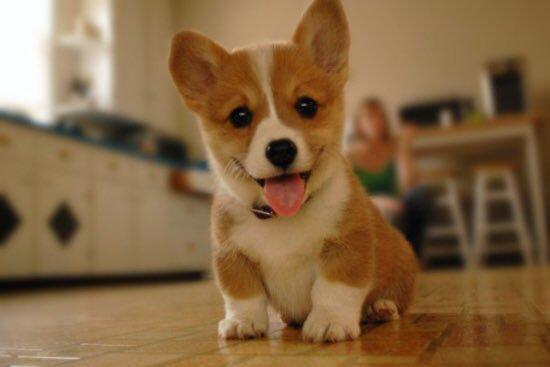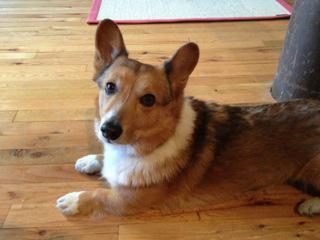The first image is the image on the left, the second image is the image on the right. For the images displayed, is the sentence "One dog has its tongue out." factually correct? Answer yes or no. Yes. The first image is the image on the left, the second image is the image on the right. Examine the images to the left and right. Is the description "One image contains a tri-color dog that is not reclining and has its body angled to the right." accurate? Answer yes or no. No. 